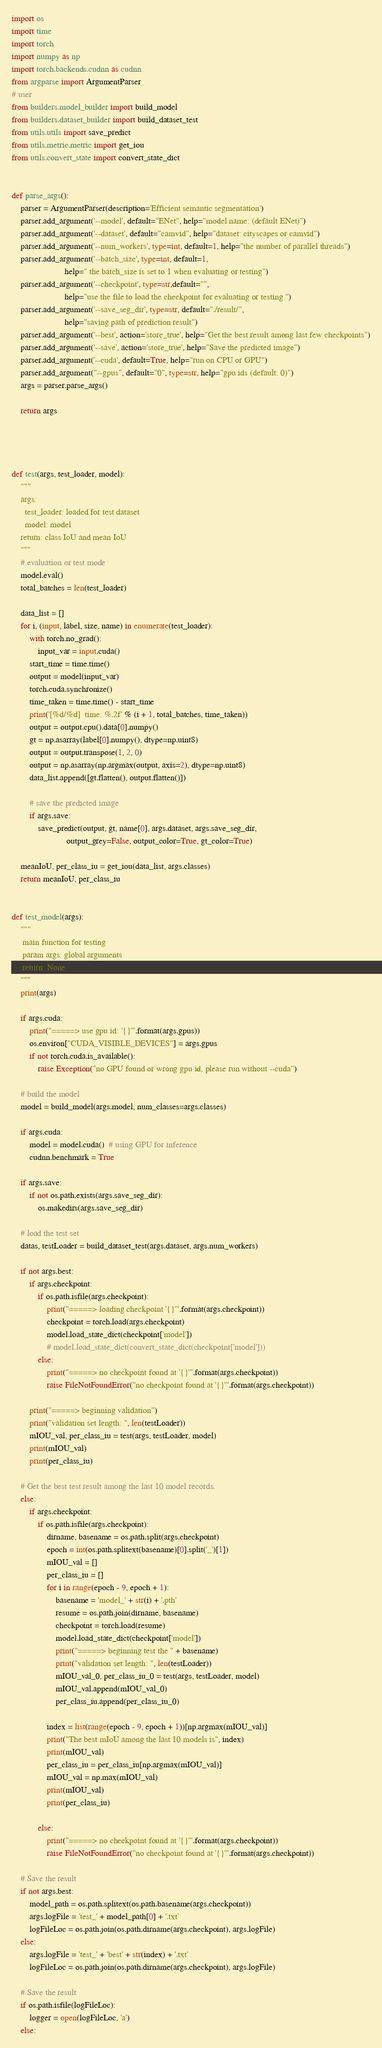<code> <loc_0><loc_0><loc_500><loc_500><_Python_>import os
import time
import torch
import numpy as np
import torch.backends.cudnn as cudnn
from argparse import ArgumentParser
# user
from builders.model_builder import build_model
from builders.dataset_builder import build_dataset_test
from utils.utils import save_predict
from utils.metric.metric import get_iou
from utils.convert_state import convert_state_dict


def parse_args():
    parser = ArgumentParser(description='Efficient semantic segmentation')
    parser.add_argument('--model', default="ENet", help="model name: (default ENet)")
    parser.add_argument('--dataset', default="camvid", help="dataset: cityscapes or camvid")
    parser.add_argument('--num_workers', type=int, default=1, help="the number of parallel threads")
    parser.add_argument('--batch_size', type=int, default=1,
                        help=" the batch_size is set to 1 when evaluating or testing")
    parser.add_argument('--checkpoint', type=str,default="",
                        help="use the file to load the checkpoint for evaluating or testing ")
    parser.add_argument('--save_seg_dir', type=str, default="./result/",
                        help="saving path of prediction result")
    parser.add_argument('--best', action='store_true', help="Get the best result among last few checkpoints")
    parser.add_argument('--save', action='store_true', help="Save the predicted image")
    parser.add_argument('--cuda', default=True, help="run on CPU or GPU")
    parser.add_argument("--gpus", default="0", type=str, help="gpu ids (default: 0)")
    args = parser.parse_args()

    return args




def test(args, test_loader, model):
    """
    args:
      test_loader: loaded for test dataset
      model: model
    return: class IoU and mean IoU
    """
    # evaluation or test mode
    model.eval()
    total_batches = len(test_loader)

    data_list = []
    for i, (input, label, size, name) in enumerate(test_loader):
        with torch.no_grad():
            input_var = input.cuda()
        start_time = time.time()
        output = model(input_var)
        torch.cuda.synchronize()
        time_taken = time.time() - start_time
        print('[%d/%d]  time: %.2f' % (i + 1, total_batches, time_taken))
        output = output.cpu().data[0].numpy()
        gt = np.asarray(label[0].numpy(), dtype=np.uint8)
        output = output.transpose(1, 2, 0)
        output = np.asarray(np.argmax(output, axis=2), dtype=np.uint8)
        data_list.append([gt.flatten(), output.flatten()])

        # save the predicted image
        if args.save:
            save_predict(output, gt, name[0], args.dataset, args.save_seg_dir,
                         output_grey=False, output_color=True, gt_color=True)

    meanIoU, per_class_iu = get_iou(data_list, args.classes)
    return meanIoU, per_class_iu


def test_model(args):
    """
     main function for testing
     param args: global arguments
     return: None
    """
    print(args)

    if args.cuda:
        print("=====> use gpu id: '{}'".format(args.gpus))
        os.environ["CUDA_VISIBLE_DEVICES"] = args.gpus
        if not torch.cuda.is_available():
            raise Exception("no GPU found or wrong gpu id, please run without --cuda")

    # build the model
    model = build_model(args.model, num_classes=args.classes)

    if args.cuda:
        model = model.cuda()  # using GPU for inference
        cudnn.benchmark = True

    if args.save:
        if not os.path.exists(args.save_seg_dir):
            os.makedirs(args.save_seg_dir)

    # load the test set
    datas, testLoader = build_dataset_test(args.dataset, args.num_workers)

    if not args.best:
        if args.checkpoint:
            if os.path.isfile(args.checkpoint):
                print("=====> loading checkpoint '{}'".format(args.checkpoint))
                checkpoint = torch.load(args.checkpoint)
                model.load_state_dict(checkpoint['model'])
                # model.load_state_dict(convert_state_dict(checkpoint['model']))
            else:
                print("=====> no checkpoint found at '{}'".format(args.checkpoint))
                raise FileNotFoundError("no checkpoint found at '{}'".format(args.checkpoint))

        print("=====> beginning validation")
        print("validation set length: ", len(testLoader))
        mIOU_val, per_class_iu = test(args, testLoader, model)
        print(mIOU_val)
        print(per_class_iu)

    # Get the best test result among the last 10 model records.
    else:
        if args.checkpoint:
            if os.path.isfile(args.checkpoint):
                dirname, basename = os.path.split(args.checkpoint)
                epoch = int(os.path.splitext(basename)[0].split('_')[1])
                mIOU_val = []
                per_class_iu = []
                for i in range(epoch - 9, epoch + 1):
                    basename = 'model_' + str(i) + '.pth'
                    resume = os.path.join(dirname, basename)
                    checkpoint = torch.load(resume)
                    model.load_state_dict(checkpoint['model'])
                    print("=====> beginning test the " + basename)
                    print("validation set length: ", len(testLoader))
                    mIOU_val_0, per_class_iu_0 = test(args, testLoader, model)
                    mIOU_val.append(mIOU_val_0)
                    per_class_iu.append(per_class_iu_0)

                index = list(range(epoch - 9, epoch + 1))[np.argmax(mIOU_val)]
                print("The best mIoU among the last 10 models is", index)
                print(mIOU_val)
                per_class_iu = per_class_iu[np.argmax(mIOU_val)]
                mIOU_val = np.max(mIOU_val)
                print(mIOU_val)
                print(per_class_iu)

            else:
                print("=====> no checkpoint found at '{}'".format(args.checkpoint))
                raise FileNotFoundError("no checkpoint found at '{}'".format(args.checkpoint))

    # Save the result
    if not args.best:
        model_path = os.path.splitext(os.path.basename(args.checkpoint))
        args.logFile = 'test_' + model_path[0] + '.txt'
        logFileLoc = os.path.join(os.path.dirname(args.checkpoint), args.logFile)
    else:
        args.logFile = 'test_' + 'best' + str(index) + '.txt'
        logFileLoc = os.path.join(os.path.dirname(args.checkpoint), args.logFile)

    # Save the result
    if os.path.isfile(logFileLoc):
        logger = open(logFileLoc, 'a')
    else:</code> 